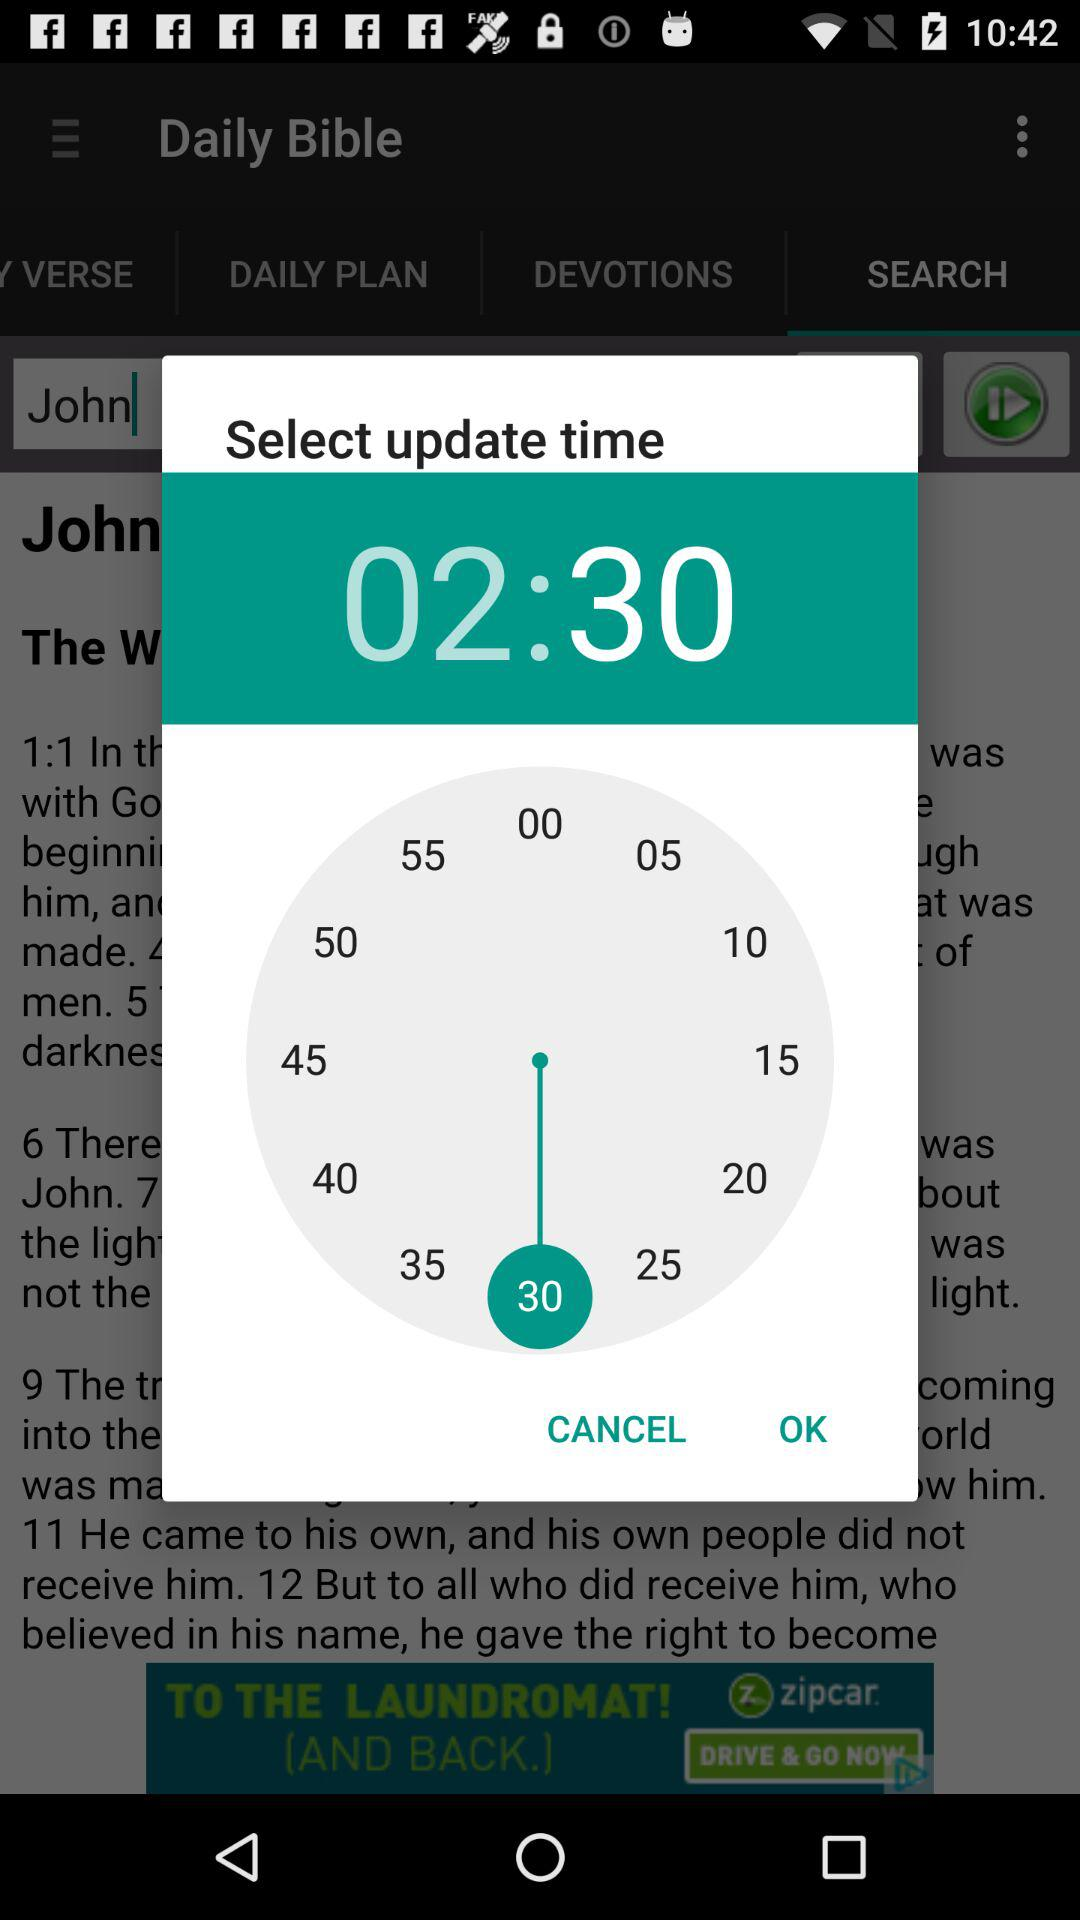What is the selected time? The selected time is 2:30. 